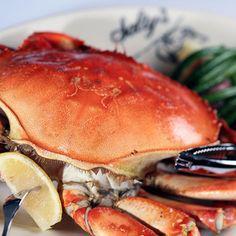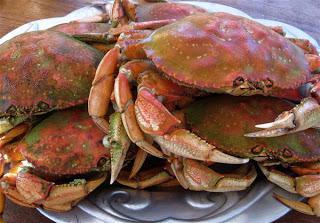The first image is the image on the left, the second image is the image on the right. Considering the images on both sides, is "Green vegetables are served in the plate with the crab in one of the dishes." valid? Answer yes or no. Yes. 